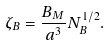Convert formula to latex. <formula><loc_0><loc_0><loc_500><loc_500>\zeta _ { B } = \frac { B _ { M } } { a ^ { 3 } } N _ { B } ^ { 1 / 2 } .</formula> 